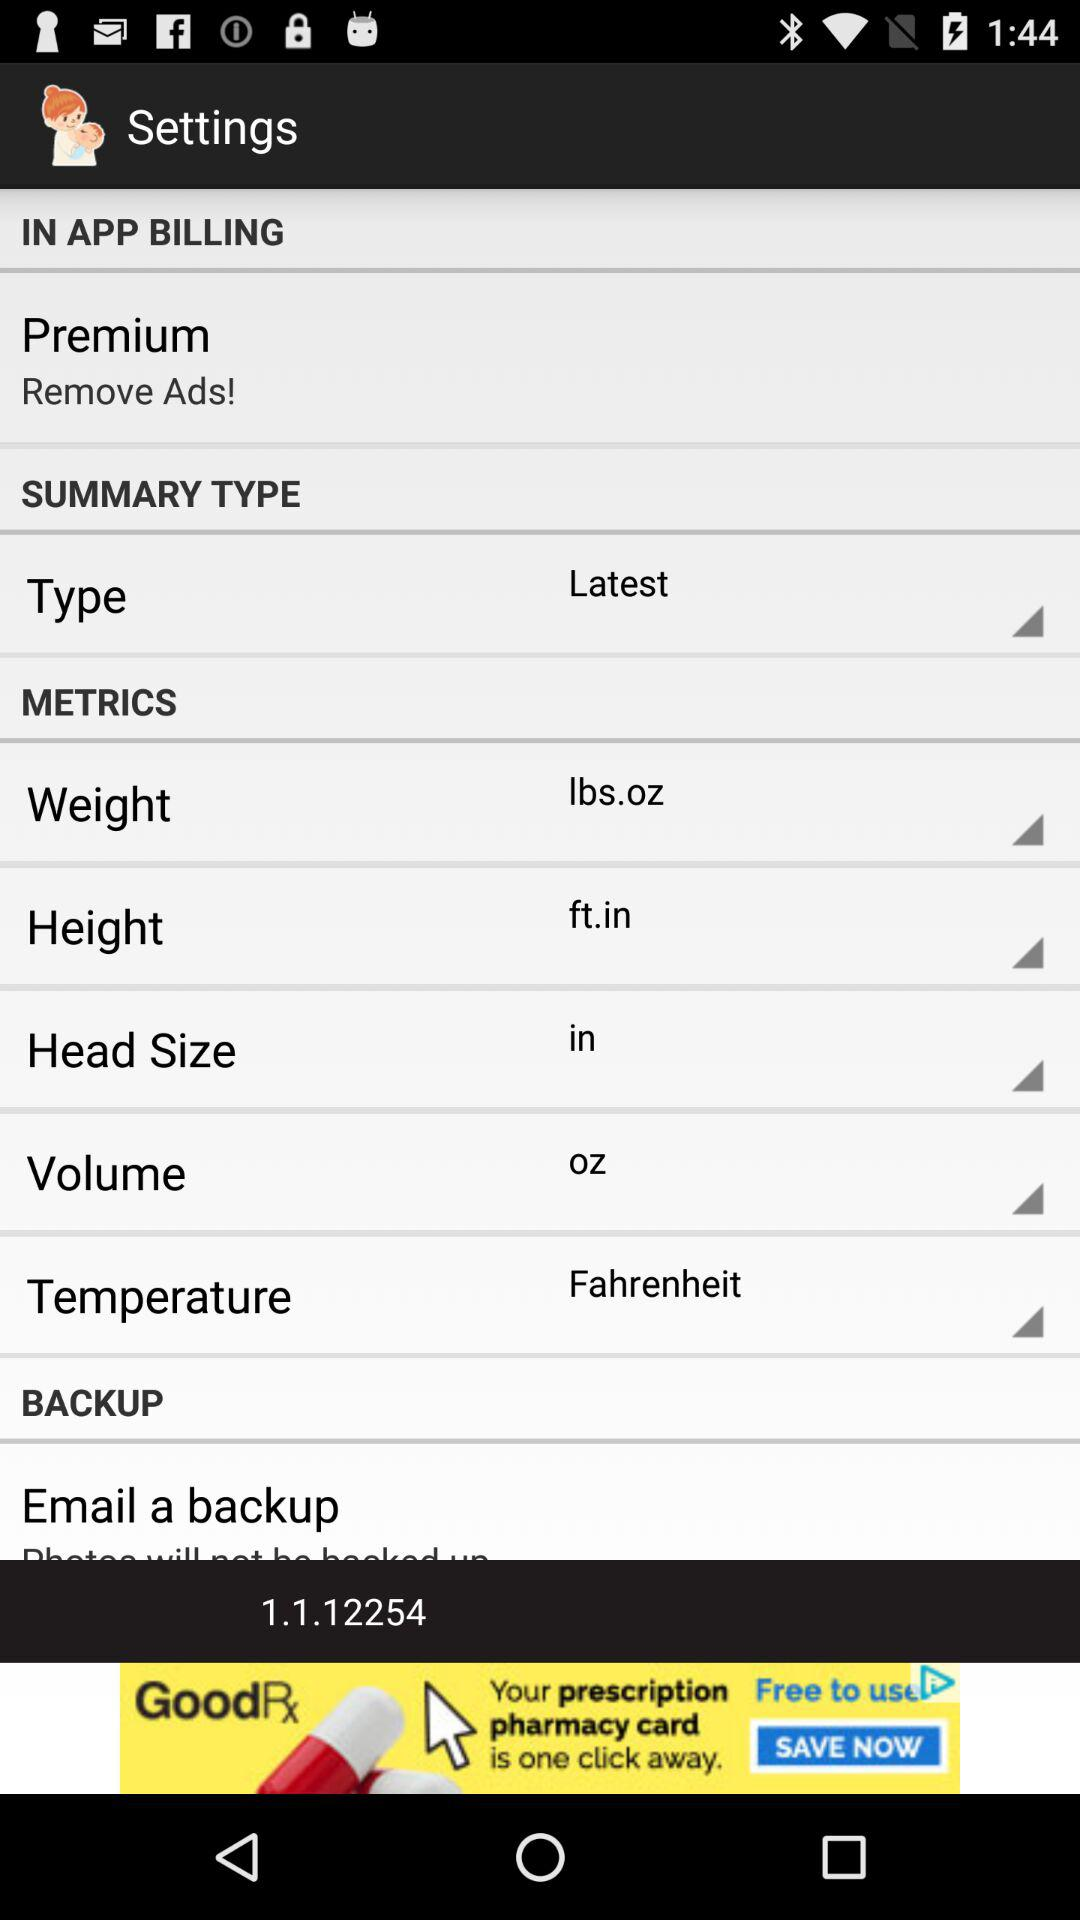What is the measurement unit of length selected on the application?
When the provided information is insufficient, respond with <no answer>. <no answer> 